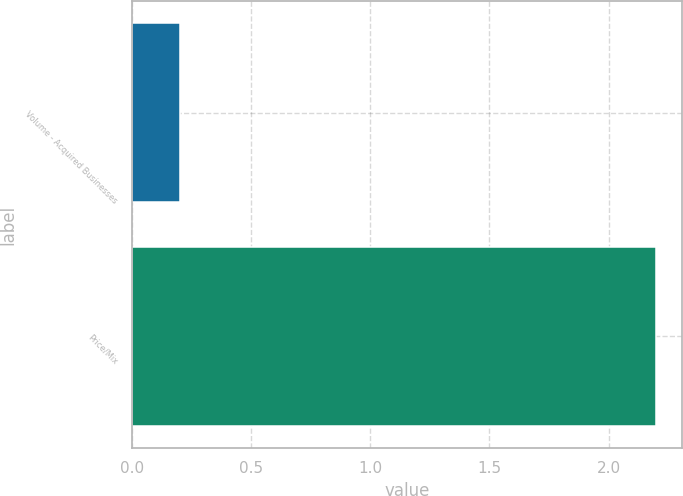Convert chart. <chart><loc_0><loc_0><loc_500><loc_500><bar_chart><fcel>Volume - Acquired Businesses<fcel>Price/Mix<nl><fcel>0.2<fcel>2.2<nl></chart> 